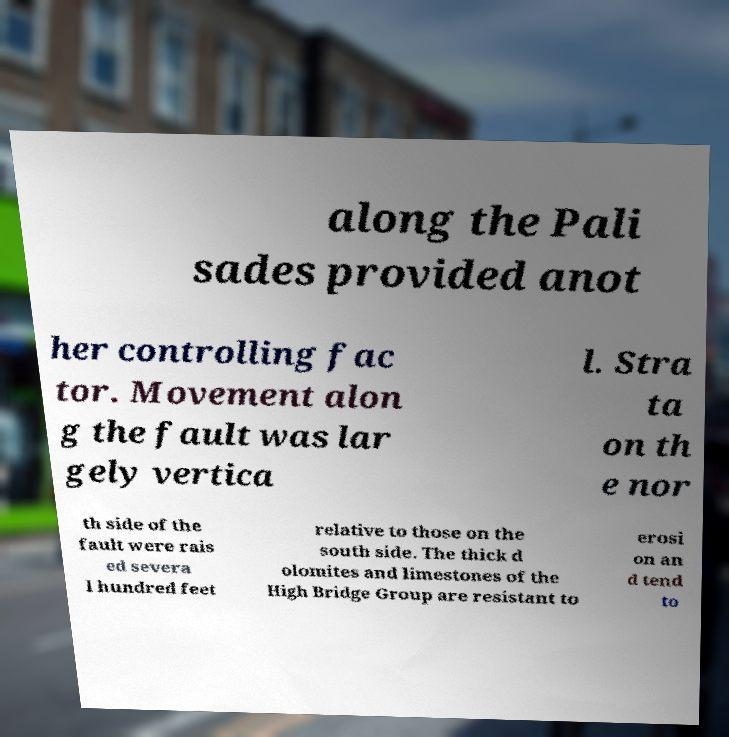Can you read and provide the text displayed in the image?This photo seems to have some interesting text. Can you extract and type it out for me? along the Pali sades provided anot her controlling fac tor. Movement alon g the fault was lar gely vertica l. Stra ta on th e nor th side of the fault were rais ed severa l hundred feet relative to those on the south side. The thick d olomites and limestones of the High Bridge Group are resistant to erosi on an d tend to 